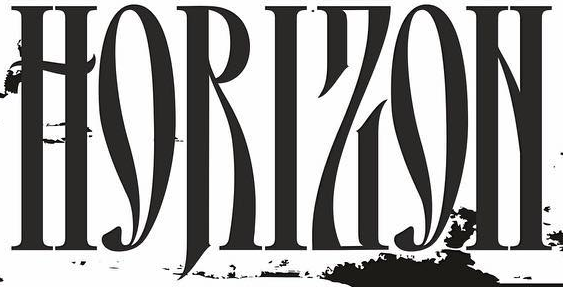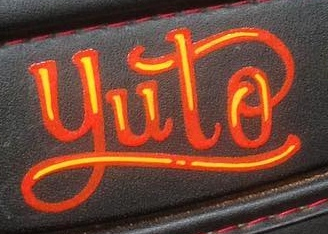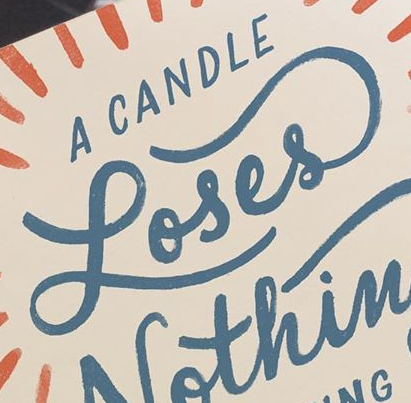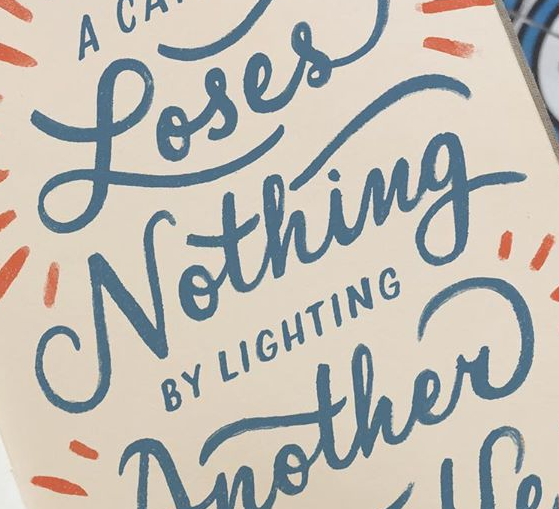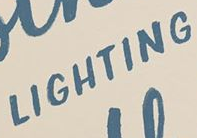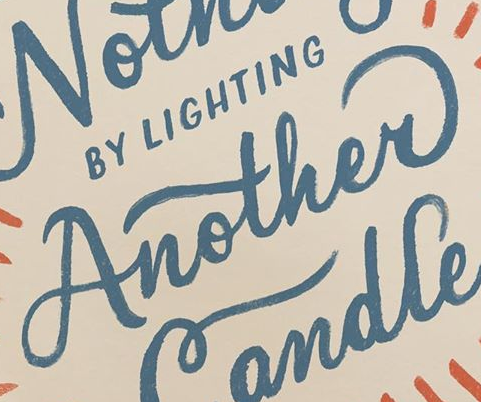What words can you see in these images in sequence, separated by a semicolon? HORIZON; yuto; Loses; Nothing; LIGHTING; Another 